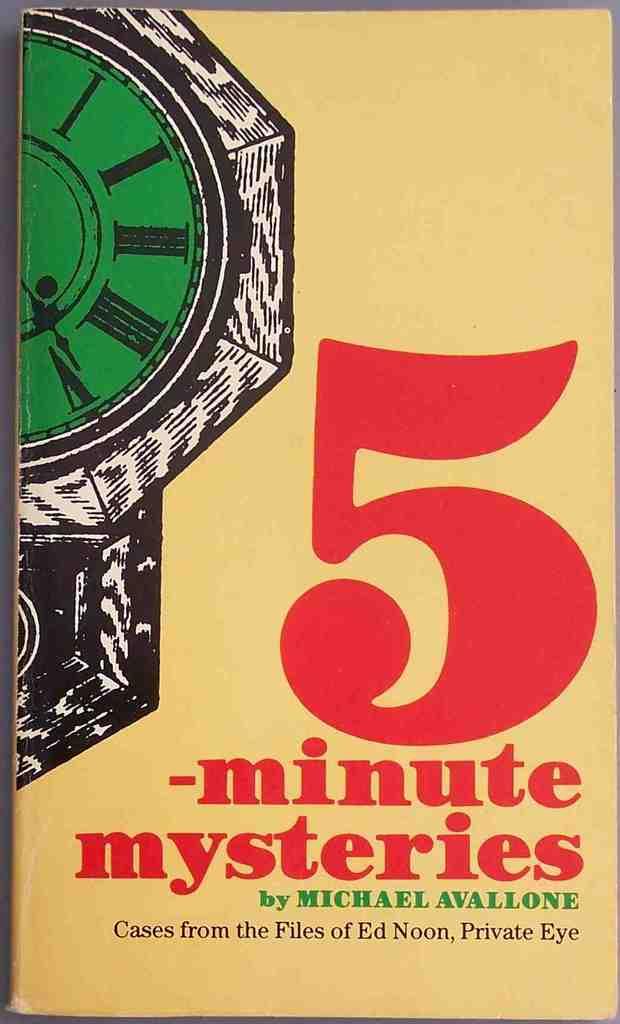How long does it take to read each mystery story?
Your response must be concise. 5 minutes. Who is the author?
Give a very brief answer. Michael avallone. 